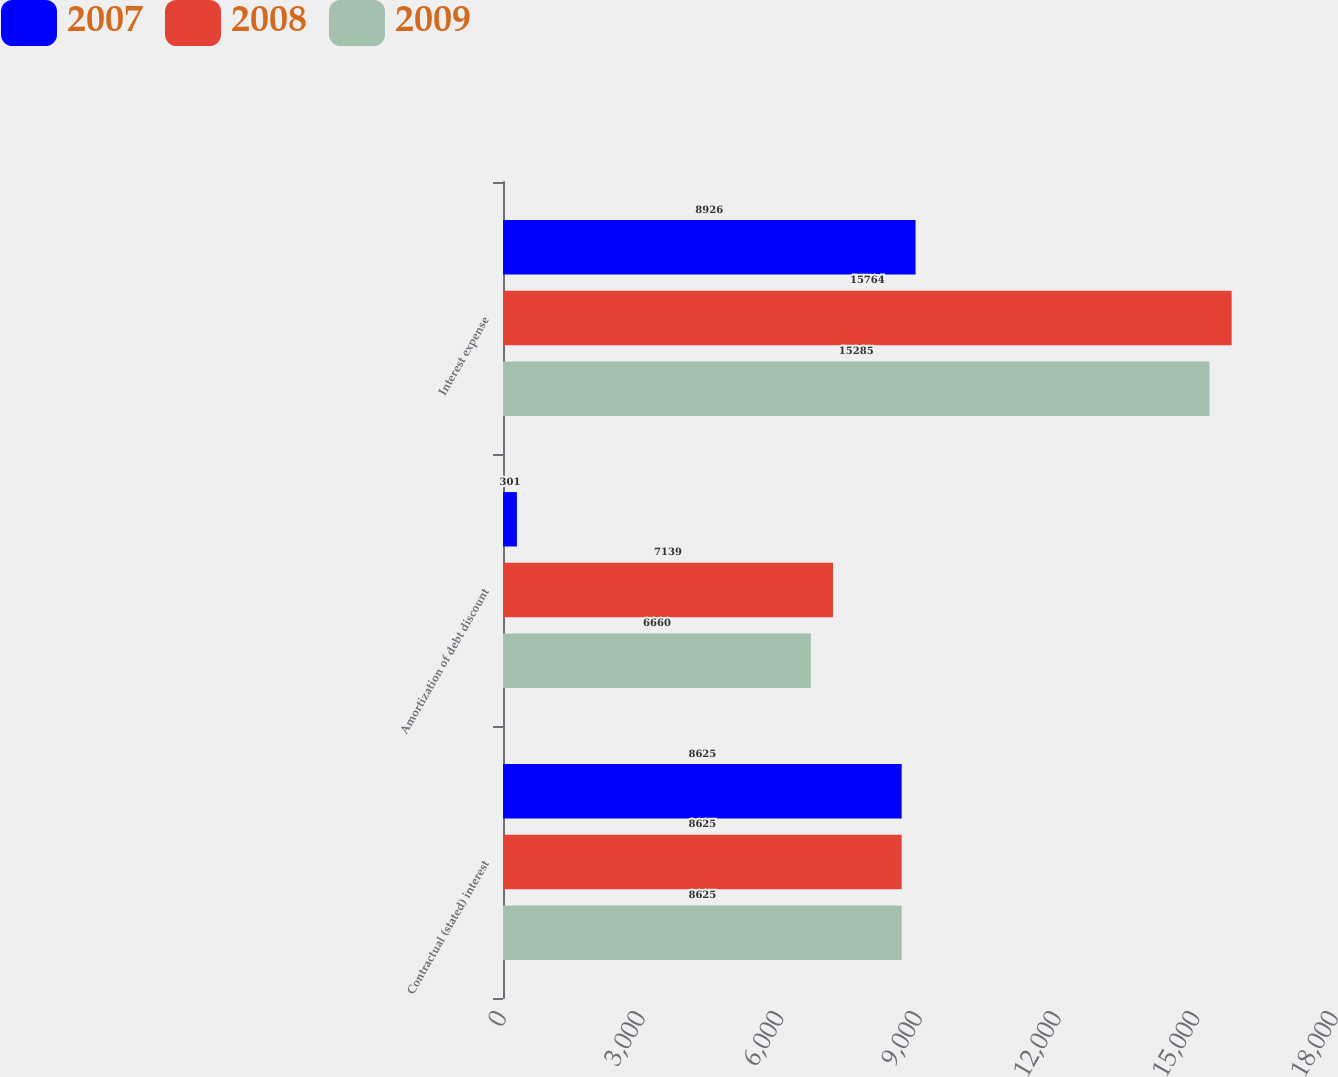Convert chart to OTSL. <chart><loc_0><loc_0><loc_500><loc_500><stacked_bar_chart><ecel><fcel>Contractual (stated) interest<fcel>Amortization of debt discount<fcel>Interest expense<nl><fcel>2007<fcel>8625<fcel>301<fcel>8926<nl><fcel>2008<fcel>8625<fcel>7139<fcel>15764<nl><fcel>2009<fcel>8625<fcel>6660<fcel>15285<nl></chart> 